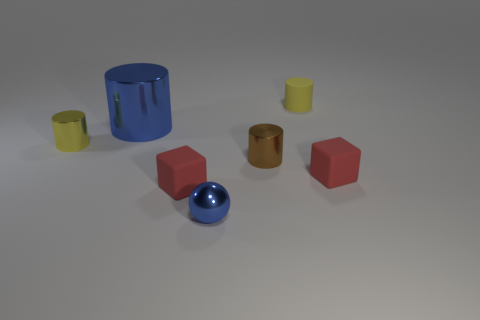What number of red blocks are made of the same material as the big blue object?
Your response must be concise. 0. Does the yellow shiny thing have the same shape as the tiny brown metal thing?
Provide a succinct answer. Yes. There is a blue thing that is in front of the red thing that is to the right of the yellow rubber thing right of the tiny brown metal thing; what size is it?
Make the answer very short. Small. Is there a tiny yellow matte cylinder on the left side of the small metallic cylinder in front of the tiny yellow shiny cylinder?
Make the answer very short. No. There is a blue object that is behind the tiny cylinder to the left of the tiny blue metal object; what number of tiny red matte things are behind it?
Provide a succinct answer. 0. What is the color of the rubber object that is both on the right side of the tiny blue thing and in front of the yellow rubber cylinder?
Provide a succinct answer. Red. What number of other matte cylinders have the same color as the tiny matte cylinder?
Your answer should be compact. 0. What number of blocks are big objects or blue metal things?
Offer a terse response. 0. There is a rubber cylinder that is the same size as the brown metal cylinder; what color is it?
Keep it short and to the point. Yellow. There is a yellow metallic cylinder to the left of the cylinder that is behind the blue metal cylinder; are there any red rubber blocks that are behind it?
Ensure brevity in your answer.  No. 